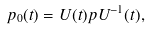Convert formula to latex. <formula><loc_0><loc_0><loc_500><loc_500>p _ { 0 } ( t ) = U ( t ) p U ^ { - 1 } ( t ) ,</formula> 